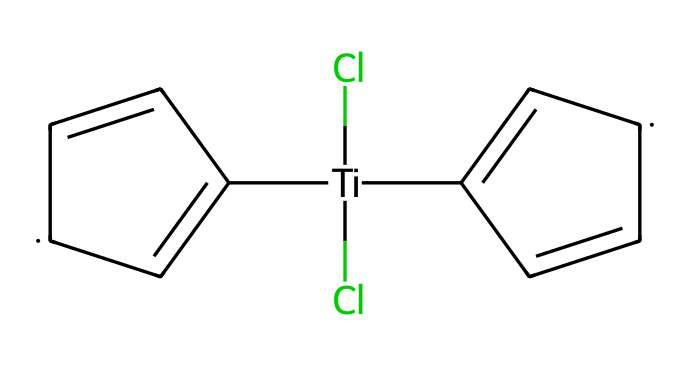What is the central metal atom in titanocene dichloride? The SMILES representation indicates the presence of titanium ([Ti]) at the core of the molecule, suggesting it is the central metal atom.
Answer: titanium How many chlorine atoms are present in the molecule? From the SMILES notation, there are two chlorine atoms represented by (Cl)(Cl), indicating that titanocene dichloride contains two Cl atoms.
Answer: 2 What is the oxidation state of titanium in this compound? In titanocene dichloride, titanium is bonded to two chlorine atoms and two cyclopentadienyl rings, typically giving titanium an oxidation state of +4 in this scenario.
Answer: +4 How many rings are present in the molecular structure? The SMILES shows two distinct cyclopentadienyl rings (C1=C[CH]C=C1), indicating that there are two ring structures in titanocene dichloride.
Answer: 2 What type of ligand are the chloride ions in titanocene dichloride? In the context of titanocene dichloride, the chloride ions act as bidentate ligands, meaning they can bond to the central titanium atom through their two available lone pairs.
Answer: bidentate What is the primary use of titanocene dichloride in industry? Titanocene dichloride is primarily utilized as a catalyst in the production of specialized polymers, particularly in processes like Ziegler-Natta polymerization.
Answer: catalyst 